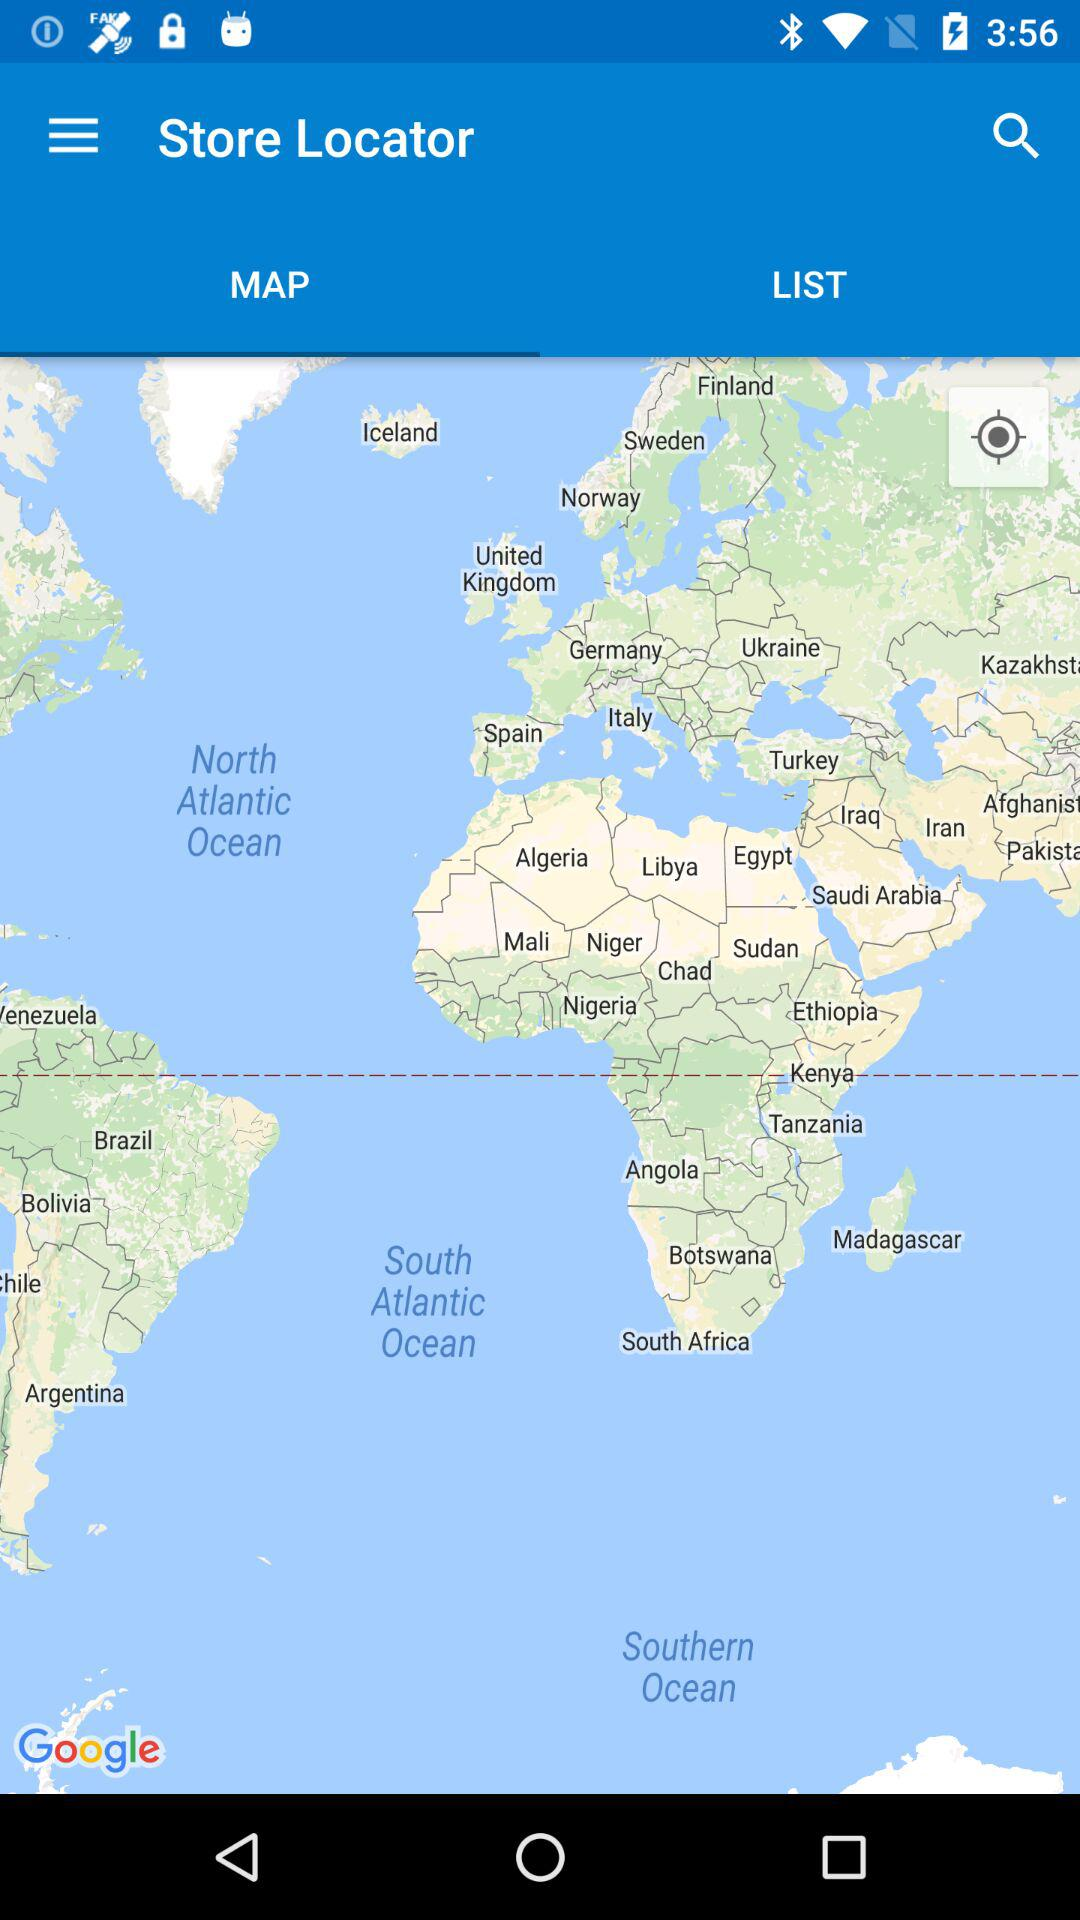Which tab is selected? The selected tab is "MAP". 